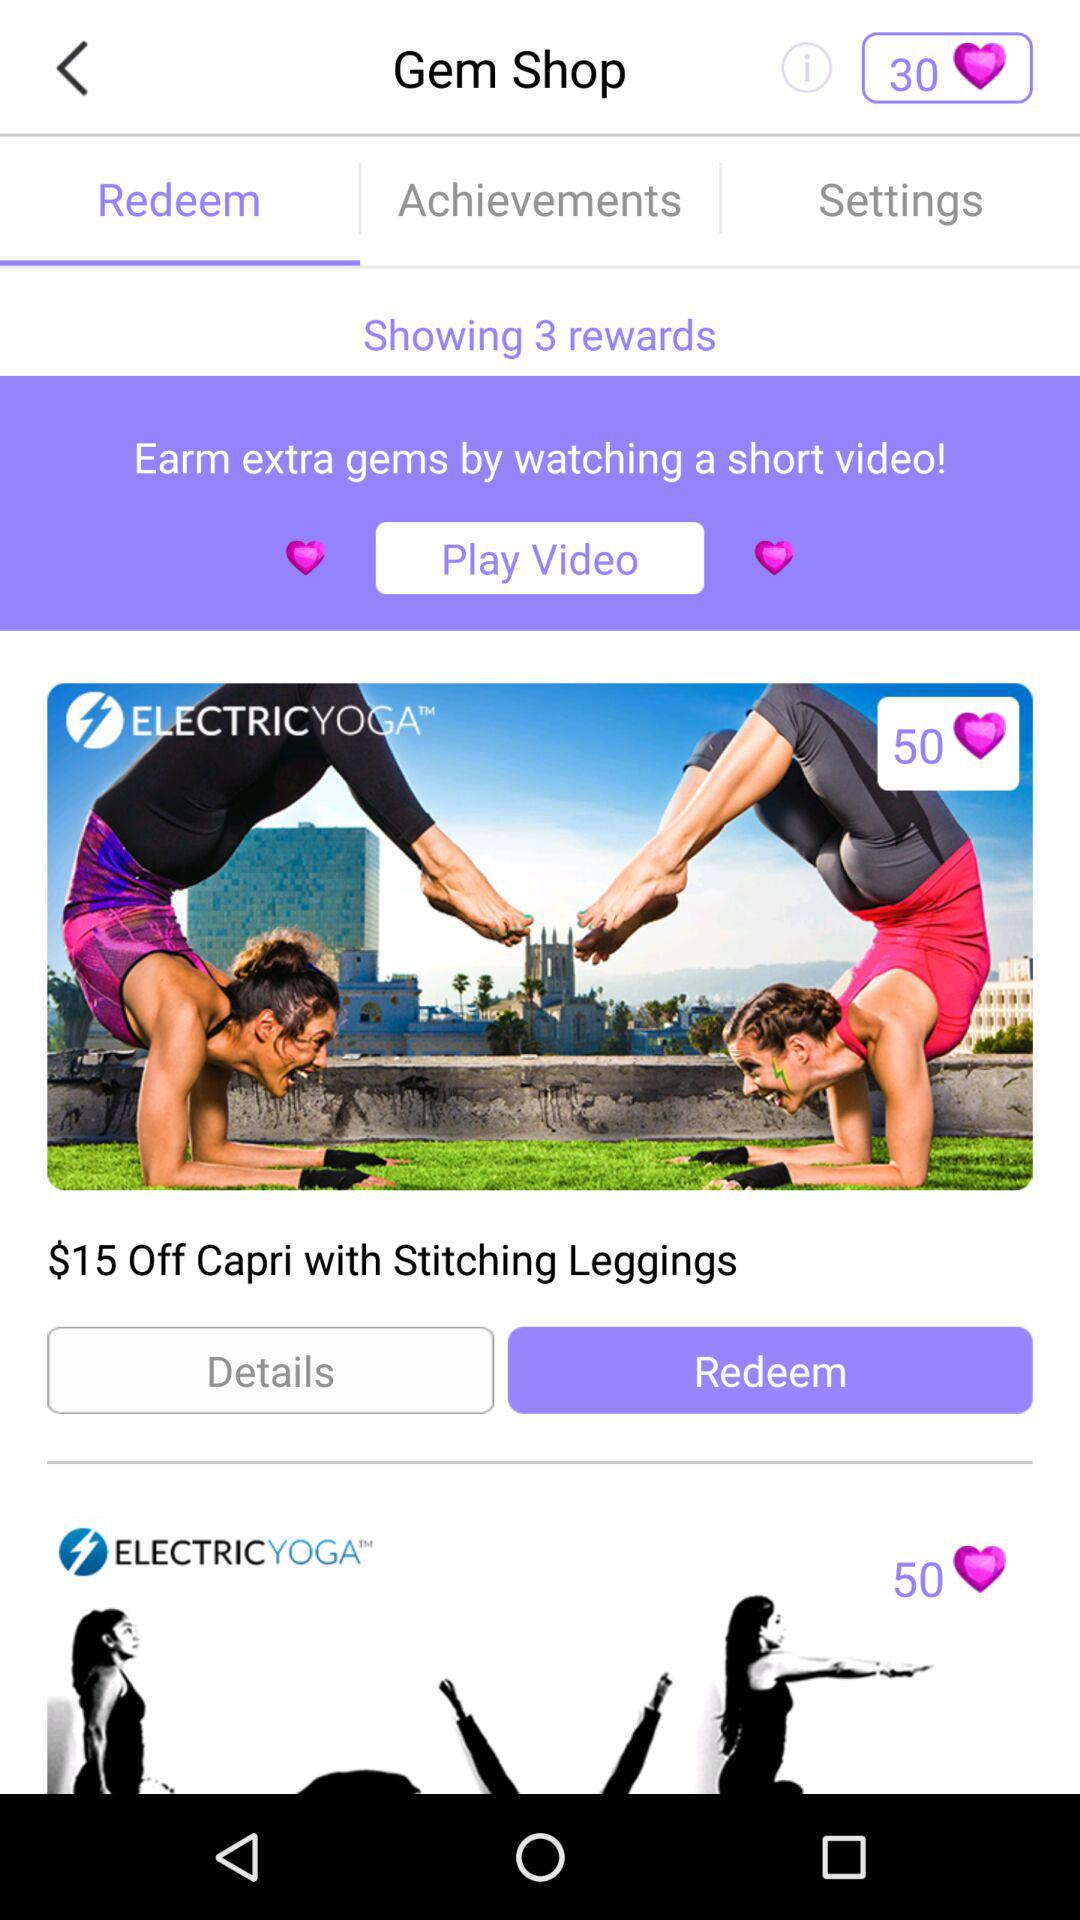How many gems can be redeemed on "Capri with Stitching Leggings"? There are 50 gems that can be redeemed on "Capri with Stitching Leggings". 